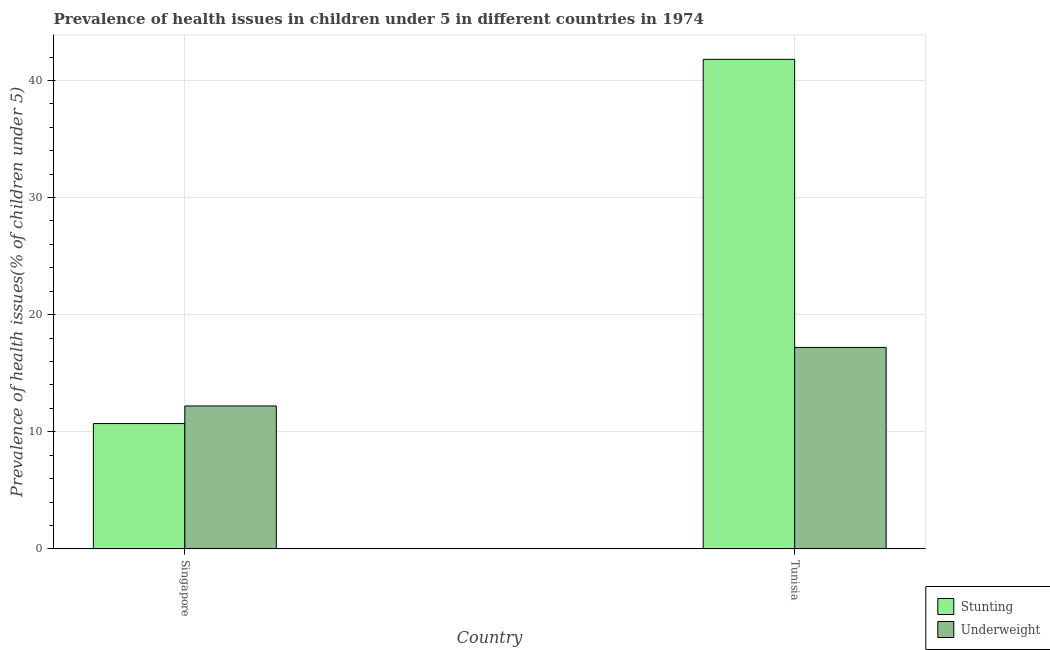How many different coloured bars are there?
Your response must be concise. 2. How many groups of bars are there?
Give a very brief answer. 2. Are the number of bars per tick equal to the number of legend labels?
Provide a succinct answer. Yes. Are the number of bars on each tick of the X-axis equal?
Give a very brief answer. Yes. How many bars are there on the 2nd tick from the left?
Your response must be concise. 2. What is the label of the 2nd group of bars from the left?
Your answer should be very brief. Tunisia. What is the percentage of underweight children in Tunisia?
Keep it short and to the point. 17.2. Across all countries, what is the maximum percentage of underweight children?
Keep it short and to the point. 17.2. Across all countries, what is the minimum percentage of underweight children?
Keep it short and to the point. 12.2. In which country was the percentage of underweight children maximum?
Offer a terse response. Tunisia. In which country was the percentage of underweight children minimum?
Give a very brief answer. Singapore. What is the total percentage of underweight children in the graph?
Make the answer very short. 29.4. What is the difference between the percentage of underweight children in Singapore and that in Tunisia?
Offer a terse response. -5. What is the difference between the percentage of underweight children in Tunisia and the percentage of stunted children in Singapore?
Your answer should be compact. 6.5. What is the average percentage of stunted children per country?
Your response must be concise. 26.25. In how many countries, is the percentage of underweight children greater than 6 %?
Your answer should be compact. 2. What is the ratio of the percentage of underweight children in Singapore to that in Tunisia?
Give a very brief answer. 0.71. Is the percentage of stunted children in Singapore less than that in Tunisia?
Your answer should be very brief. Yes. In how many countries, is the percentage of stunted children greater than the average percentage of stunted children taken over all countries?
Your answer should be compact. 1. What does the 2nd bar from the left in Singapore represents?
Your answer should be very brief. Underweight. What does the 1st bar from the right in Singapore represents?
Make the answer very short. Underweight. How many bars are there?
Your answer should be very brief. 4. Are all the bars in the graph horizontal?
Provide a short and direct response. No. What is the difference between two consecutive major ticks on the Y-axis?
Your answer should be very brief. 10. Are the values on the major ticks of Y-axis written in scientific E-notation?
Keep it short and to the point. No. Does the graph contain grids?
Offer a terse response. Yes. Where does the legend appear in the graph?
Give a very brief answer. Bottom right. What is the title of the graph?
Provide a short and direct response. Prevalence of health issues in children under 5 in different countries in 1974. What is the label or title of the Y-axis?
Ensure brevity in your answer.  Prevalence of health issues(% of children under 5). What is the Prevalence of health issues(% of children under 5) of Stunting in Singapore?
Your answer should be compact. 10.7. What is the Prevalence of health issues(% of children under 5) of Underweight in Singapore?
Your answer should be compact. 12.2. What is the Prevalence of health issues(% of children under 5) in Stunting in Tunisia?
Ensure brevity in your answer.  41.8. What is the Prevalence of health issues(% of children under 5) of Underweight in Tunisia?
Ensure brevity in your answer.  17.2. Across all countries, what is the maximum Prevalence of health issues(% of children under 5) of Stunting?
Provide a short and direct response. 41.8. Across all countries, what is the maximum Prevalence of health issues(% of children under 5) of Underweight?
Offer a terse response. 17.2. Across all countries, what is the minimum Prevalence of health issues(% of children under 5) of Stunting?
Make the answer very short. 10.7. Across all countries, what is the minimum Prevalence of health issues(% of children under 5) of Underweight?
Your answer should be compact. 12.2. What is the total Prevalence of health issues(% of children under 5) in Stunting in the graph?
Make the answer very short. 52.5. What is the total Prevalence of health issues(% of children under 5) of Underweight in the graph?
Your response must be concise. 29.4. What is the difference between the Prevalence of health issues(% of children under 5) of Stunting in Singapore and that in Tunisia?
Your response must be concise. -31.1. What is the difference between the Prevalence of health issues(% of children under 5) of Stunting in Singapore and the Prevalence of health issues(% of children under 5) of Underweight in Tunisia?
Offer a terse response. -6.5. What is the average Prevalence of health issues(% of children under 5) in Stunting per country?
Provide a succinct answer. 26.25. What is the difference between the Prevalence of health issues(% of children under 5) in Stunting and Prevalence of health issues(% of children under 5) in Underweight in Singapore?
Provide a short and direct response. -1.5. What is the difference between the Prevalence of health issues(% of children under 5) of Stunting and Prevalence of health issues(% of children under 5) of Underweight in Tunisia?
Provide a short and direct response. 24.6. What is the ratio of the Prevalence of health issues(% of children under 5) in Stunting in Singapore to that in Tunisia?
Your answer should be very brief. 0.26. What is the ratio of the Prevalence of health issues(% of children under 5) of Underweight in Singapore to that in Tunisia?
Your response must be concise. 0.71. What is the difference between the highest and the second highest Prevalence of health issues(% of children under 5) in Stunting?
Make the answer very short. 31.1. What is the difference between the highest and the second highest Prevalence of health issues(% of children under 5) of Underweight?
Ensure brevity in your answer.  5. What is the difference between the highest and the lowest Prevalence of health issues(% of children under 5) in Stunting?
Make the answer very short. 31.1. 